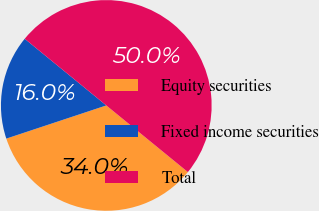Convert chart. <chart><loc_0><loc_0><loc_500><loc_500><pie_chart><fcel>Equity securities<fcel>Fixed income securities<fcel>Total<nl><fcel>34.0%<fcel>16.0%<fcel>50.0%<nl></chart> 